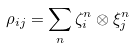Convert formula to latex. <formula><loc_0><loc_0><loc_500><loc_500>\rho _ { i j } = \sum _ { n } \zeta _ { i } ^ { n } \otimes \xi _ { j } ^ { n }</formula> 